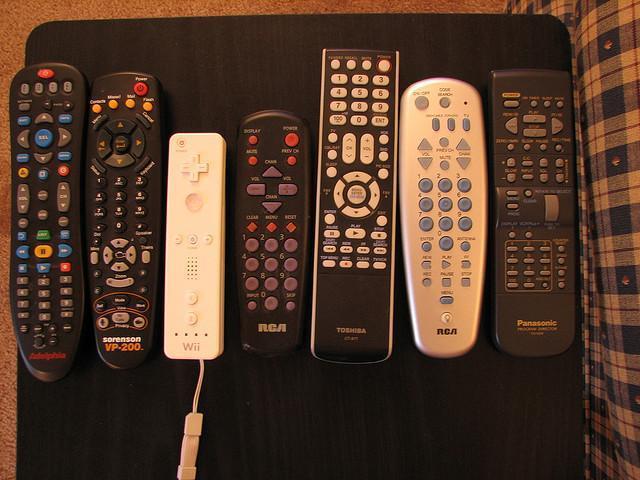How many of these devices are controllers for video game consoles?
Give a very brief answer. 1. How many remotes are there?
Give a very brief answer. 7. How many people are doing a frontside bluntslide down a rail?
Give a very brief answer. 0. 